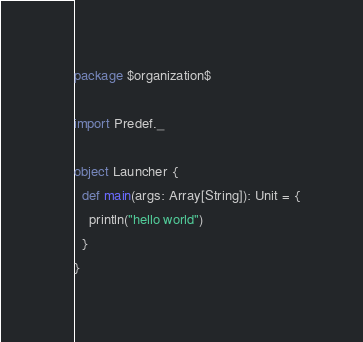<code> <loc_0><loc_0><loc_500><loc_500><_Scala_>package $organization$

import Predef._

object Launcher {
  def main(args: Array[String]): Unit = {
    println("hello world")
  }
}
</code> 